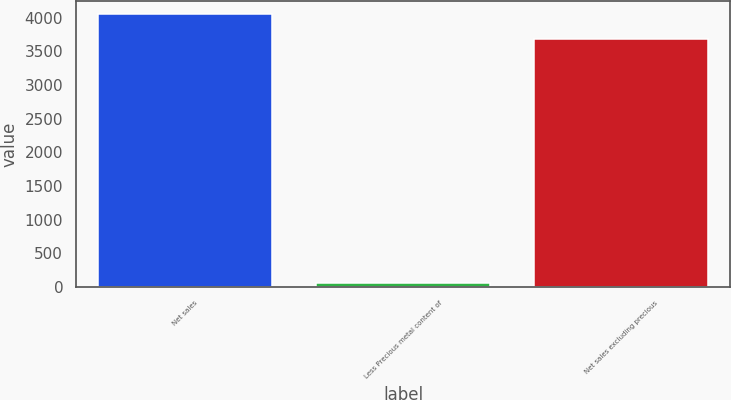<chart> <loc_0><loc_0><loc_500><loc_500><bar_chart><fcel>Net sales<fcel>Less Precious metal content of<fcel>Net sales excluding precious<nl><fcel>4049.1<fcel>64.3<fcel>3681<nl></chart> 